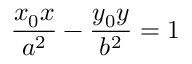Convert formula to latex. <formula><loc_0><loc_0><loc_500><loc_500>{ \frac { x _ { 0 } x } { a ^ { 2 } } } - { \frac { y _ { 0 } y } { b ^ { 2 } } } = 1</formula> 